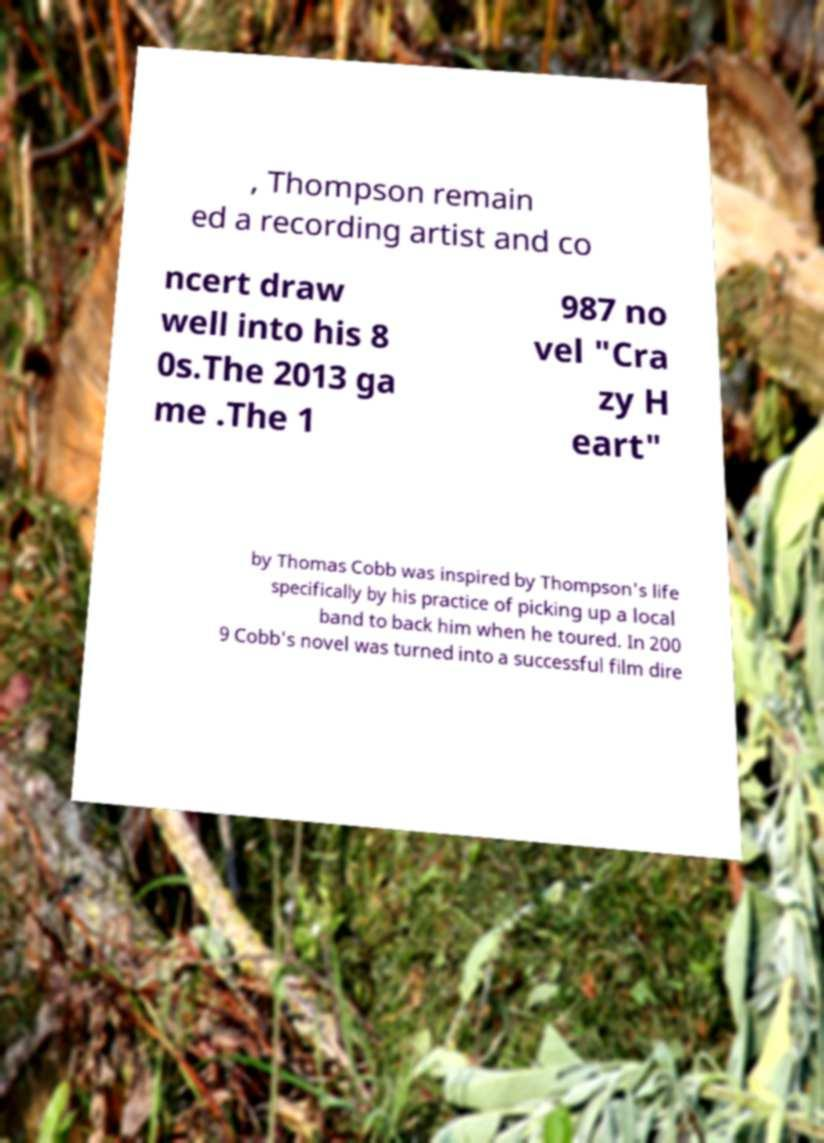Can you accurately transcribe the text from the provided image for me? , Thompson remain ed a recording artist and co ncert draw well into his 8 0s.The 2013 ga me .The 1 987 no vel "Cra zy H eart" by Thomas Cobb was inspired by Thompson's life specifically by his practice of picking up a local band to back him when he toured. In 200 9 Cobb's novel was turned into a successful film dire 